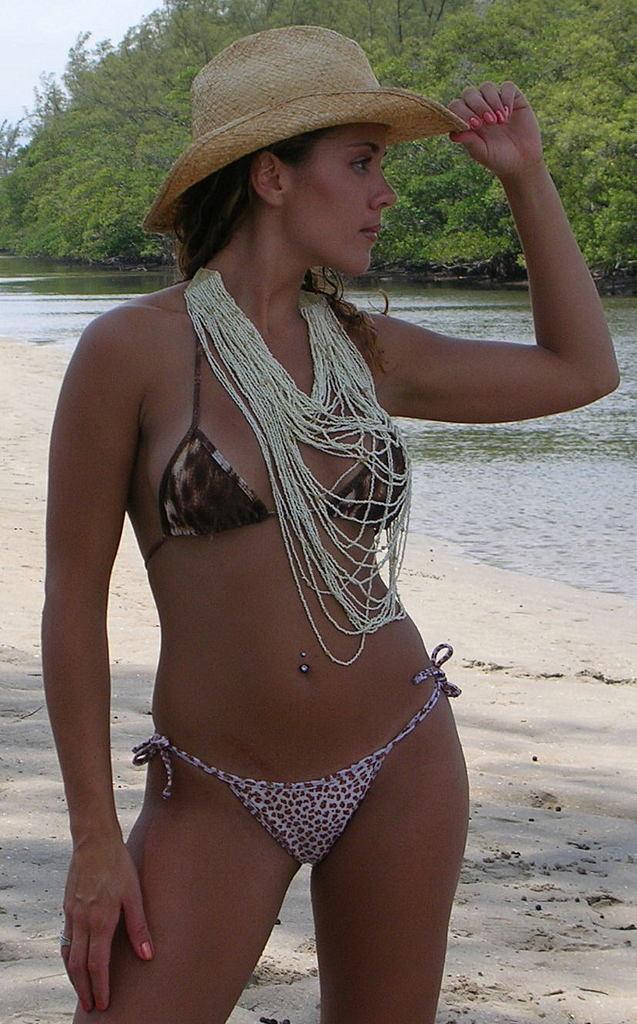In one or two sentences, can you explain what this image depicts? The woman in front of the picture wearing hat is standing. Behind her, we see water and this water might be in a lake. At the bottom of the picture, we see sand and there are trees in the background. 